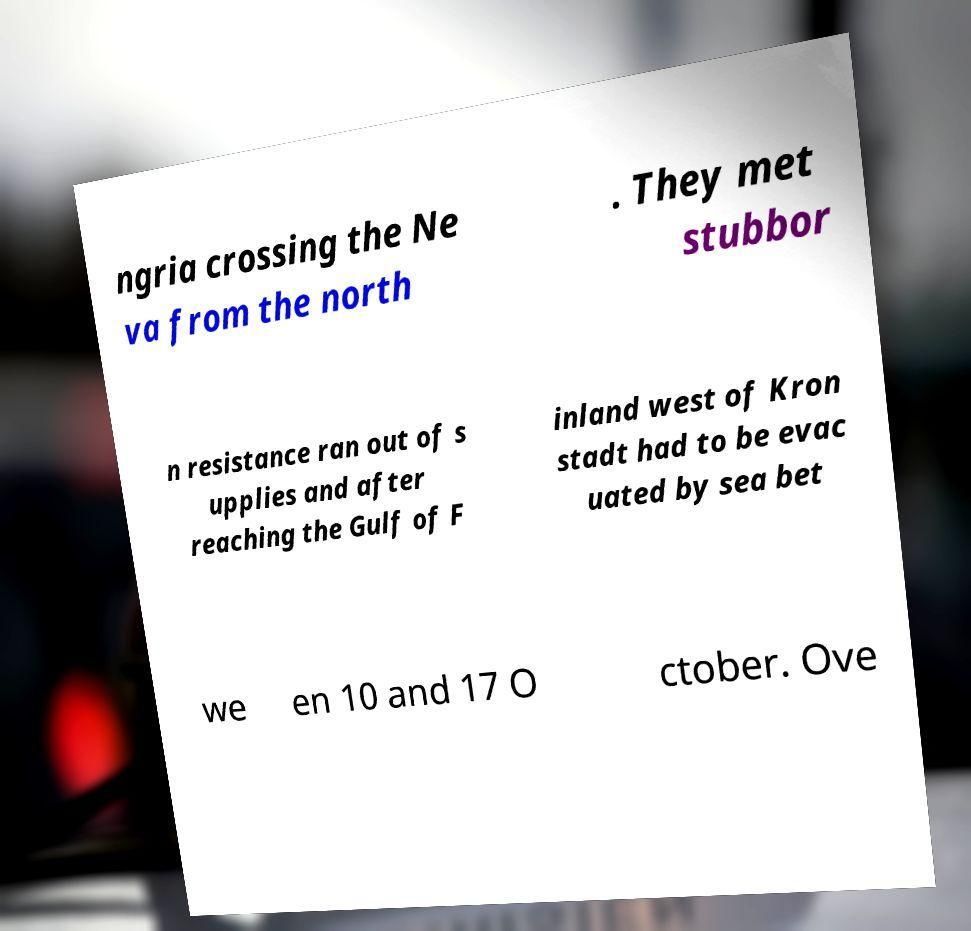Could you extract and type out the text from this image? ngria crossing the Ne va from the north . They met stubbor n resistance ran out of s upplies and after reaching the Gulf of F inland west of Kron stadt had to be evac uated by sea bet we en 10 and 17 O ctober. Ove 